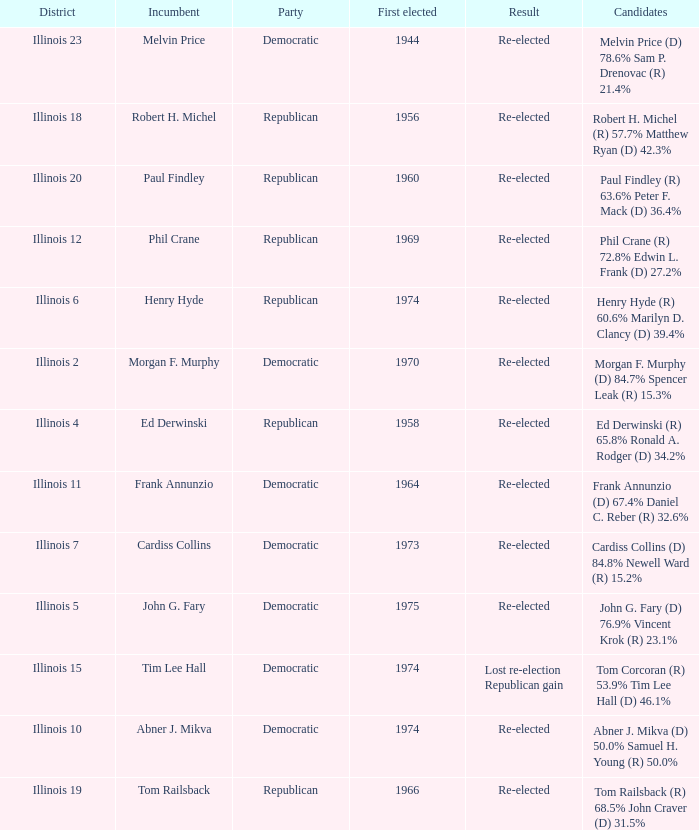Name the number of first elected for phil crane 1.0. 